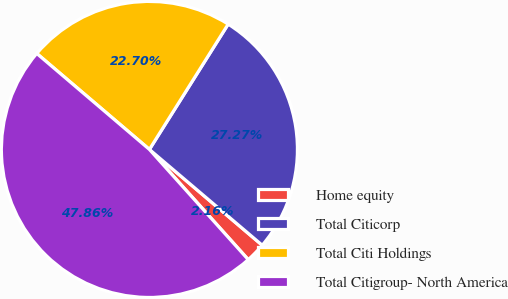Convert chart. <chart><loc_0><loc_0><loc_500><loc_500><pie_chart><fcel>Home equity<fcel>Total Citicorp<fcel>Total Citi Holdings<fcel>Total Citigroup- North America<nl><fcel>2.16%<fcel>27.27%<fcel>22.7%<fcel>47.86%<nl></chart> 